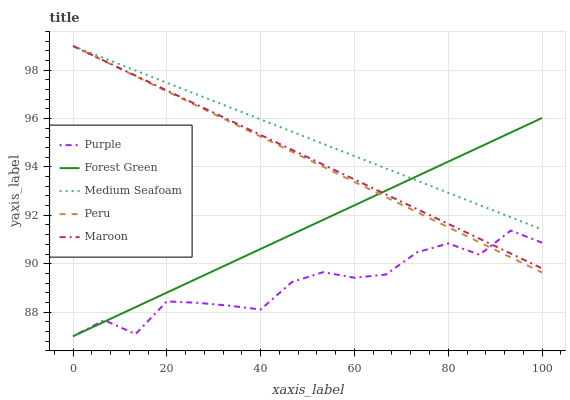Does Purple have the minimum area under the curve?
Answer yes or no. Yes. Does Medium Seafoam have the maximum area under the curve?
Answer yes or no. Yes. Does Maroon have the minimum area under the curve?
Answer yes or no. No. Does Maroon have the maximum area under the curve?
Answer yes or no. No. Is Medium Seafoam the smoothest?
Answer yes or no. Yes. Is Purple the roughest?
Answer yes or no. Yes. Is Maroon the smoothest?
Answer yes or no. No. Is Maroon the roughest?
Answer yes or no. No. Does Purple have the lowest value?
Answer yes or no. Yes. Does Maroon have the lowest value?
Answer yes or no. No. Does Peru have the highest value?
Answer yes or no. Yes. Does Forest Green have the highest value?
Answer yes or no. No. Is Purple less than Medium Seafoam?
Answer yes or no. Yes. Is Medium Seafoam greater than Purple?
Answer yes or no. Yes. Does Peru intersect Maroon?
Answer yes or no. Yes. Is Peru less than Maroon?
Answer yes or no. No. Is Peru greater than Maroon?
Answer yes or no. No. Does Purple intersect Medium Seafoam?
Answer yes or no. No. 